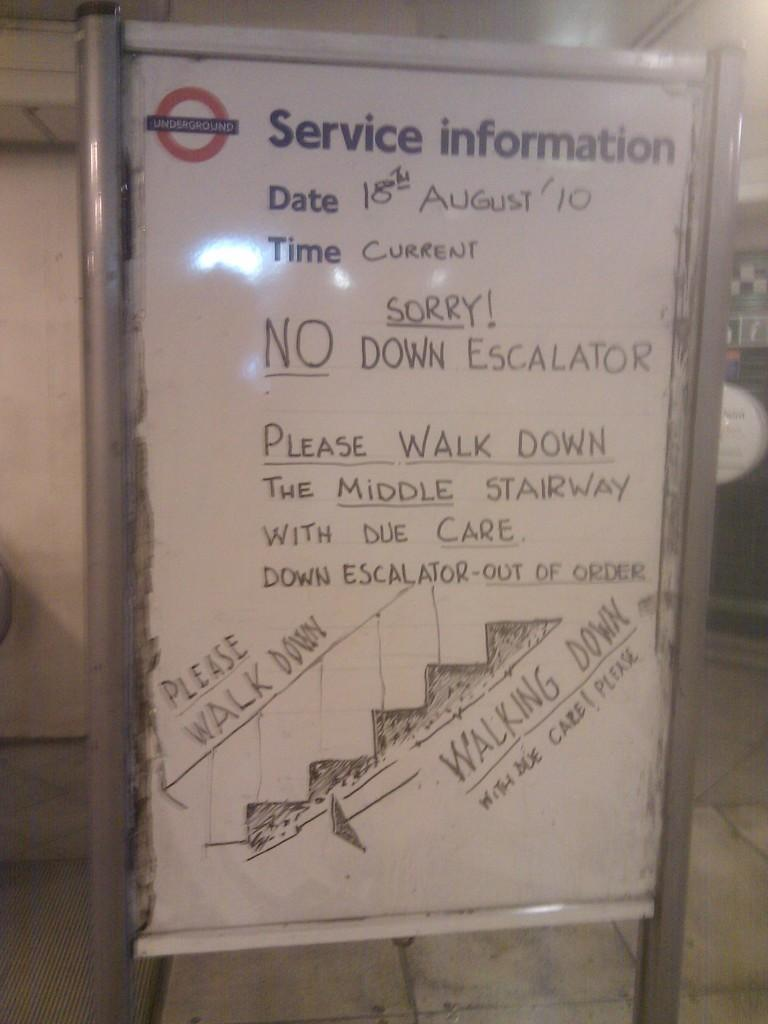Provide a one-sentence caption for the provided image. A sign standing on the tile floor with Service Information at the top. 